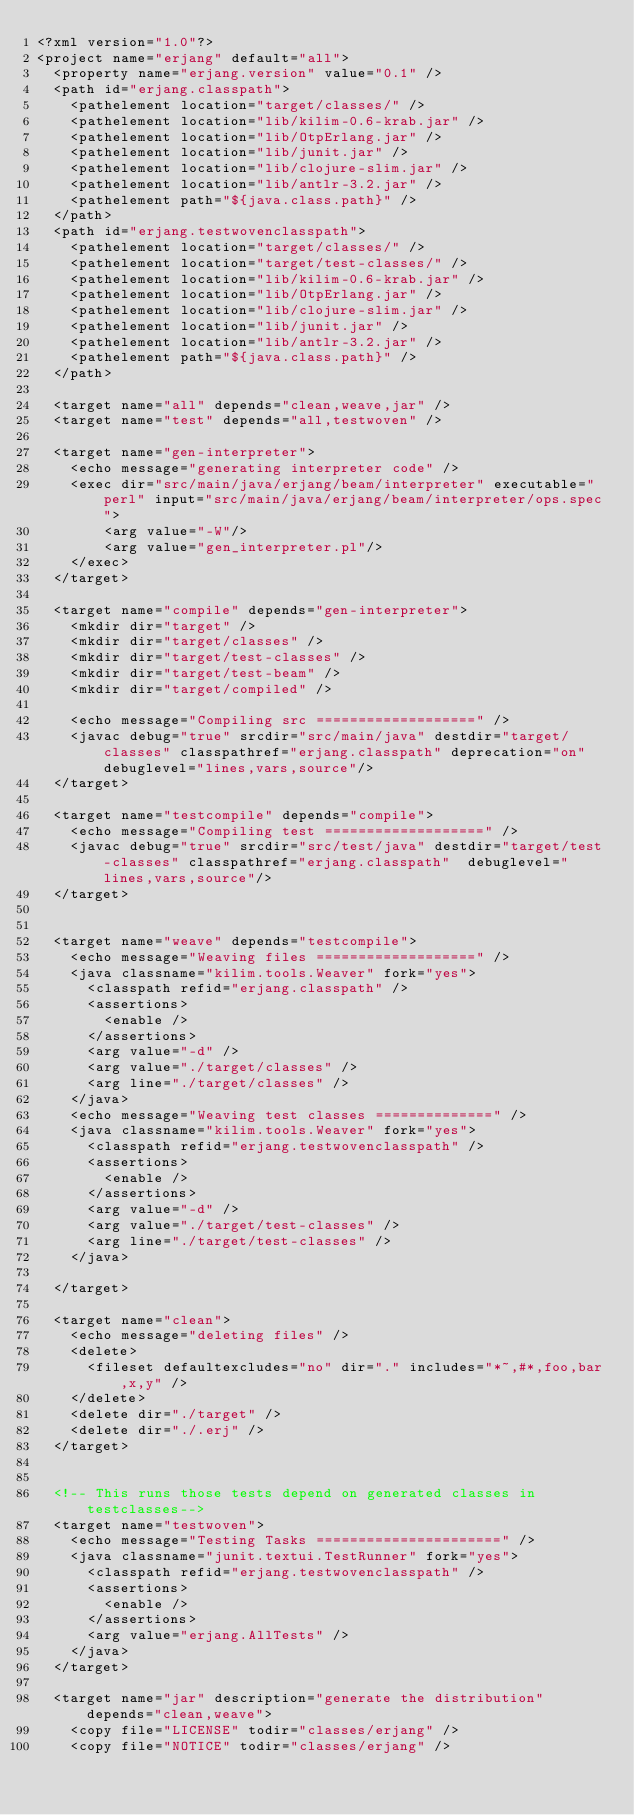<code> <loc_0><loc_0><loc_500><loc_500><_XML_><?xml version="1.0"?>
<project name="erjang" default="all">
	<property name="erjang.version" value="0.1" />
	<path id="erjang.classpath">
		<pathelement location="target/classes/" />
		<pathelement location="lib/kilim-0.6-krab.jar" />
		<pathelement location="lib/OtpErlang.jar" />
		<pathelement location="lib/junit.jar" />
		<pathelement location="lib/clojure-slim.jar" />
		<pathelement location="lib/antlr-3.2.jar" />
		<pathelement path="${java.class.path}" />
	</path>
	<path id="erjang.testwovenclasspath">
		<pathelement location="target/classes/" />
		<pathelement location="target/test-classes/" />
		<pathelement location="lib/kilim-0.6-krab.jar" />
		<pathelement location="lib/OtpErlang.jar" />
		<pathelement location="lib/clojure-slim.jar" />
		<pathelement location="lib/junit.jar" />
		<pathelement location="lib/antlr-3.2.jar" />
		<pathelement path="${java.class.path}" />
	</path>

	<target name="all" depends="clean,weave,jar" />
	<target name="test" depends="all,testwoven" />

	<target name="gen-interpreter">
		<echo message="generating interpreter code" />
		<exec dir="src/main/java/erjang/beam/interpreter" executable="perl" input="src/main/java/erjang/beam/interpreter/ops.spec">
		    <arg value="-W"/>
		    <arg value="gen_interpreter.pl"/>
		</exec>
	</target>

	<target name="compile" depends="gen-interpreter">
		<mkdir dir="target" />
		<mkdir dir="target/classes" />
		<mkdir dir="target/test-classes" />
		<mkdir dir="target/test-beam" />
		<mkdir dir="target/compiled" />

		<echo message="Compiling src ===================" />
		<javac debug="true" srcdir="src/main/java" destdir="target/classes" classpathref="erjang.classpath" deprecation="on" debuglevel="lines,vars,source"/>
	</target>

	<target name="testcompile" depends="compile">
		<echo message="Compiling test ===================" />
		<javac debug="true" srcdir="src/test/java" destdir="target/test-classes" classpathref="erjang.classpath"  debuglevel="lines,vars,source"/>
	</target>


	<target name="weave" depends="testcompile">
		<echo message="Weaving files ===================" />
		<java classname="kilim.tools.Weaver" fork="yes">
			<classpath refid="erjang.classpath" />
			<assertions>
				<enable />
			</assertions>
			<arg value="-d" />
			<arg value="./target/classes" />
			<arg line="./target/classes" />
		</java>
		<echo message="Weaving test classes ==============" />
		<java classname="kilim.tools.Weaver" fork="yes">
			<classpath refid="erjang.testwovenclasspath" />
			<assertions>
				<enable />
			</assertions>
			<arg value="-d" />
			<arg value="./target/test-classes" />
			<arg line="./target/test-classes" />
		</java>

	</target>

	<target name="clean">
		<echo message="deleting files" />
		<delete>
			<fileset defaultexcludes="no" dir="." includes="*~,#*,foo,bar,x,y" />
		</delete>
		<delete dir="./target" />
		<delete dir="./.erj" />
	</target>


	<!-- This runs those tests depend on generated classes in testclasses-->
	<target name="testwoven">
		<echo message="Testing Tasks ======================" />
		<java classname="junit.textui.TestRunner" fork="yes">
			<classpath refid="erjang.testwovenclasspath" />
			<assertions>
				<enable />
			</assertions>
			<arg value="erjang.AllTests" />
		</java>
	</target>

	<target name="jar" description="generate the distribution" depends="clean,weave">
		<copy file="LICENSE" todir="classes/erjang" />
		<copy file="NOTICE" todir="classes/erjang" /></code> 